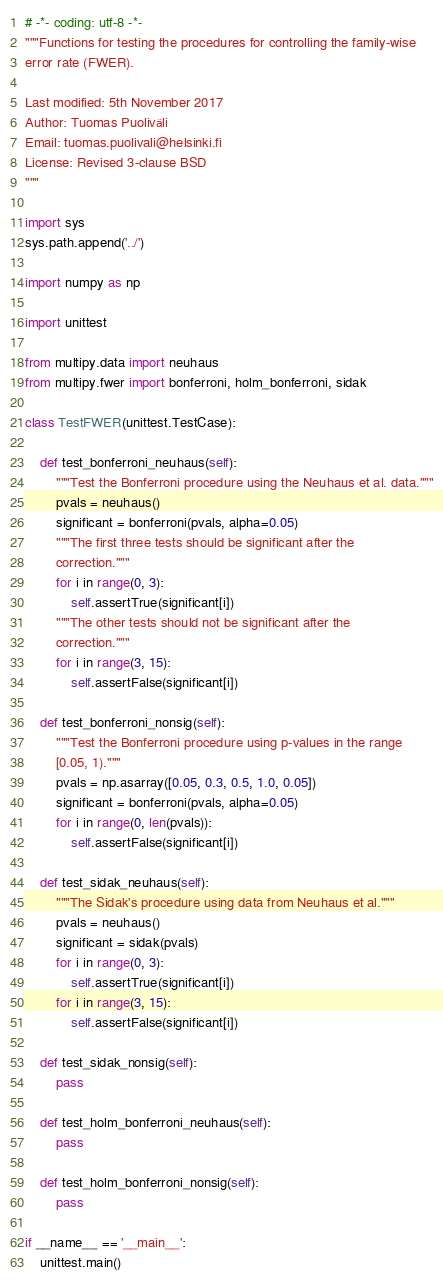<code> <loc_0><loc_0><loc_500><loc_500><_Python_># -*- coding: utf-8 -*-
"""Functions for testing the procedures for controlling the family-wise
error rate (FWER).

Last modified: 5th November 2017
Author: Tuomas Puoliväli
Email: tuomas.puolivali@helsinki.fi
License: Revised 3-clause BSD
"""

import sys
sys.path.append('../')

import numpy as np

import unittest

from multipy.data import neuhaus
from multipy.fwer import bonferroni, holm_bonferroni, sidak

class TestFWER(unittest.TestCase):

    def test_bonferroni_neuhaus(self):
        """Test the Bonferroni procedure using the Neuhaus et al. data."""
        pvals = neuhaus()
        significant = bonferroni(pvals, alpha=0.05)
        """The first three tests should be significant after the
        correction."""
        for i in range(0, 3):
            self.assertTrue(significant[i])
        """The other tests should not be significant after the
        correction."""
        for i in range(3, 15):
            self.assertFalse(significant[i])

    def test_bonferroni_nonsig(self):
        """Test the Bonferroni procedure using p-values in the range
        [0.05, 1)."""
        pvals = np.asarray([0.05, 0.3, 0.5, 1.0, 0.05])
        significant = bonferroni(pvals, alpha=0.05)
        for i in range(0, len(pvals)):
            self.assertFalse(significant[i])

    def test_sidak_neuhaus(self):
        """The Sidak's procedure using data from Neuhaus et al."""
        pvals = neuhaus()
        significant = sidak(pvals)
        for i in range(0, 3):
            self.assertTrue(significant[i])
        for i in range(3, 15):
            self.assertFalse(significant[i])

    def test_sidak_nonsig(self):
        pass

    def test_holm_bonferroni_neuhaus(self):
        pass

    def test_holm_bonferroni_nonsig(self):
        pass

if __name__ == '__main__':
    unittest.main()

</code> 